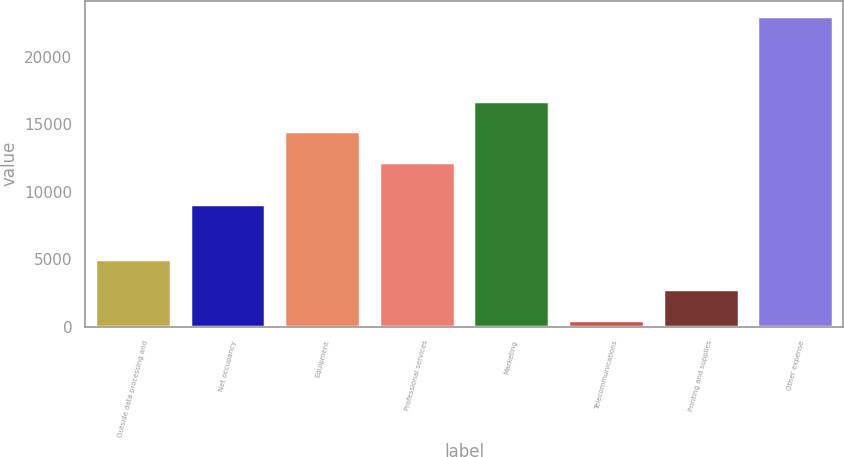Convert chart to OTSL. <chart><loc_0><loc_0><loc_500><loc_500><bar_chart><fcel>Outside data processing and<fcel>Net occupancy<fcel>Equipment<fcel>Professional services<fcel>Marketing<fcel>Telecommunications<fcel>Printing and supplies<fcel>Other expense<nl><fcel>5004.2<fcel>9055<fcel>14472.1<fcel>12223<fcel>16721.2<fcel>506<fcel>2755.1<fcel>22997<nl></chart> 